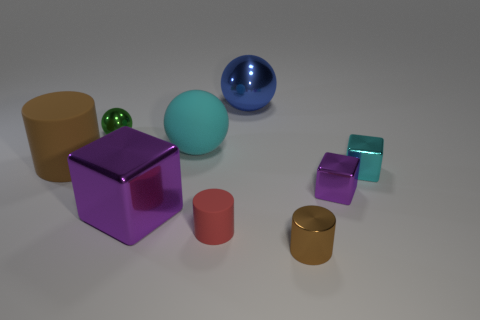Is the small brown thing made of the same material as the big object behind the green ball?
Offer a terse response. Yes. What is the size of the red matte object that is the same shape as the small brown thing?
Your response must be concise. Small. Are there an equal number of large cubes that are to the left of the brown matte object and tiny cyan things behind the blue ball?
Keep it short and to the point. Yes. How many other objects are the same material as the tiny cyan object?
Provide a succinct answer. 5. Is the number of large purple blocks in front of the big purple thing the same as the number of red matte things?
Keep it short and to the point. No. There is a blue ball; is it the same size as the purple object that is right of the big purple shiny cube?
Your answer should be compact. No. The brown thing that is in front of the brown rubber cylinder has what shape?
Offer a very short reply. Cylinder. Is there anything else that has the same shape as the large cyan object?
Provide a succinct answer. Yes. Are any cyan cubes visible?
Provide a succinct answer. Yes. Does the purple metallic cube to the right of the blue object have the same size as the purple metal object on the left side of the tiny brown shiny thing?
Provide a short and direct response. No. 